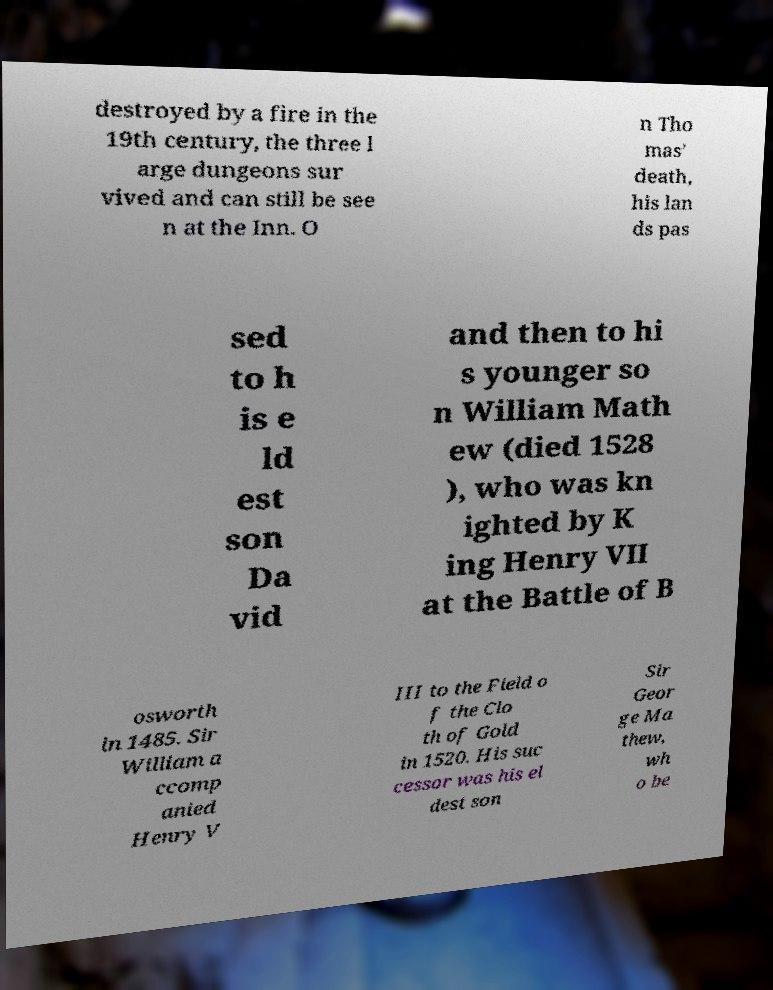There's text embedded in this image that I need extracted. Can you transcribe it verbatim? destroyed by a fire in the 19th century, the three l arge dungeons sur vived and can still be see n at the Inn. O n Tho mas' death, his lan ds pas sed to h is e ld est son Da vid and then to hi s younger so n William Math ew (died 1528 ), who was kn ighted by K ing Henry VII at the Battle of B osworth in 1485. Sir William a ccomp anied Henry V III to the Field o f the Clo th of Gold in 1520. His suc cessor was his el dest son Sir Geor ge Ma thew, wh o be 